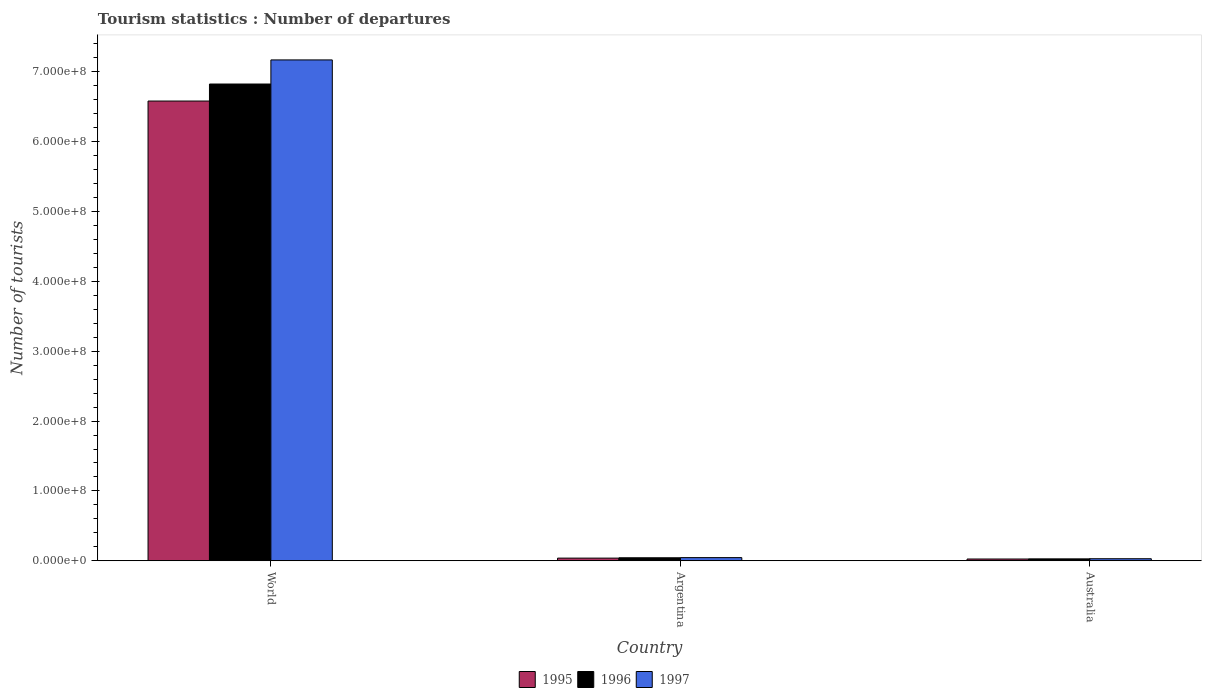Are the number of bars on each tick of the X-axis equal?
Make the answer very short. Yes. How many bars are there on the 3rd tick from the left?
Offer a terse response. 3. What is the label of the 3rd group of bars from the left?
Provide a succinct answer. Australia. In how many cases, is the number of bars for a given country not equal to the number of legend labels?
Your response must be concise. 0. What is the number of tourist departures in 1997 in Australia?
Your answer should be compact. 2.93e+06. Across all countries, what is the maximum number of tourist departures in 1997?
Your response must be concise. 7.17e+08. Across all countries, what is the minimum number of tourist departures in 1997?
Your answer should be very brief. 2.93e+06. In which country was the number of tourist departures in 1997 maximum?
Give a very brief answer. World. What is the total number of tourist departures in 1995 in the graph?
Keep it short and to the point. 6.65e+08. What is the difference between the number of tourist departures in 1995 in Argentina and that in Australia?
Provide a succinct answer. 1.30e+06. What is the difference between the number of tourist departures in 1997 in Australia and the number of tourist departures in 1995 in World?
Offer a very short reply. -6.55e+08. What is the average number of tourist departures in 1995 per country?
Your response must be concise. 2.22e+08. What is the difference between the number of tourist departures of/in 1995 and number of tourist departures of/in 1997 in World?
Your answer should be very brief. -5.89e+07. In how many countries, is the number of tourist departures in 1996 greater than 640000000?
Your response must be concise. 1. What is the ratio of the number of tourist departures in 1995 in Argentina to that in Australia?
Your answer should be very brief. 1.51. Is the number of tourist departures in 1997 in Argentina less than that in World?
Keep it short and to the point. Yes. Is the difference between the number of tourist departures in 1995 in Argentina and Australia greater than the difference between the number of tourist departures in 1997 in Argentina and Australia?
Provide a succinct answer. No. What is the difference between the highest and the second highest number of tourist departures in 1997?
Ensure brevity in your answer.  7.14e+08. What is the difference between the highest and the lowest number of tourist departures in 1995?
Keep it short and to the point. 6.56e+08. What does the 1st bar from the right in Australia represents?
Provide a short and direct response. 1997. Is it the case that in every country, the sum of the number of tourist departures in 1995 and number of tourist departures in 1997 is greater than the number of tourist departures in 1996?
Your answer should be compact. Yes. How many bars are there?
Your answer should be very brief. 9. What is the difference between two consecutive major ticks on the Y-axis?
Keep it short and to the point. 1.00e+08. What is the title of the graph?
Give a very brief answer. Tourism statistics : Number of departures. What is the label or title of the Y-axis?
Offer a terse response. Number of tourists. What is the Number of tourists in 1995 in World?
Provide a short and direct response. 6.58e+08. What is the Number of tourists of 1996 in World?
Provide a short and direct response. 6.83e+08. What is the Number of tourists in 1997 in World?
Your answer should be very brief. 7.17e+08. What is the Number of tourists of 1995 in Argentina?
Keep it short and to the point. 3.82e+06. What is the Number of tourists of 1996 in Argentina?
Ensure brevity in your answer.  4.30e+06. What is the Number of tourists in 1997 in Argentina?
Keep it short and to the point. 4.52e+06. What is the Number of tourists of 1995 in Australia?
Ensure brevity in your answer.  2.52e+06. What is the Number of tourists in 1996 in Australia?
Provide a succinct answer. 2.73e+06. What is the Number of tourists in 1997 in Australia?
Your response must be concise. 2.93e+06. Across all countries, what is the maximum Number of tourists of 1995?
Provide a short and direct response. 6.58e+08. Across all countries, what is the maximum Number of tourists in 1996?
Ensure brevity in your answer.  6.83e+08. Across all countries, what is the maximum Number of tourists of 1997?
Your response must be concise. 7.17e+08. Across all countries, what is the minimum Number of tourists of 1995?
Ensure brevity in your answer.  2.52e+06. Across all countries, what is the minimum Number of tourists in 1996?
Keep it short and to the point. 2.73e+06. Across all countries, what is the minimum Number of tourists of 1997?
Your answer should be compact. 2.93e+06. What is the total Number of tourists in 1995 in the graph?
Your answer should be compact. 6.65e+08. What is the total Number of tourists of 1996 in the graph?
Your answer should be compact. 6.90e+08. What is the total Number of tourists in 1997 in the graph?
Make the answer very short. 7.25e+08. What is the difference between the Number of tourists in 1995 in World and that in Argentina?
Give a very brief answer. 6.54e+08. What is the difference between the Number of tourists in 1996 in World and that in Argentina?
Give a very brief answer. 6.78e+08. What is the difference between the Number of tourists in 1997 in World and that in Argentina?
Provide a succinct answer. 7.13e+08. What is the difference between the Number of tourists in 1995 in World and that in Australia?
Offer a terse response. 6.56e+08. What is the difference between the Number of tourists in 1996 in World and that in Australia?
Provide a succinct answer. 6.80e+08. What is the difference between the Number of tourists in 1997 in World and that in Australia?
Provide a succinct answer. 7.14e+08. What is the difference between the Number of tourists in 1995 in Argentina and that in Australia?
Provide a short and direct response. 1.30e+06. What is the difference between the Number of tourists of 1996 in Argentina and that in Australia?
Keep it short and to the point. 1.56e+06. What is the difference between the Number of tourists in 1997 in Argentina and that in Australia?
Provide a succinct answer. 1.58e+06. What is the difference between the Number of tourists in 1995 in World and the Number of tourists in 1996 in Argentina?
Provide a succinct answer. 6.54e+08. What is the difference between the Number of tourists in 1995 in World and the Number of tourists in 1997 in Argentina?
Keep it short and to the point. 6.54e+08. What is the difference between the Number of tourists of 1996 in World and the Number of tourists of 1997 in Argentina?
Ensure brevity in your answer.  6.78e+08. What is the difference between the Number of tourists of 1995 in World and the Number of tourists of 1996 in Australia?
Ensure brevity in your answer.  6.56e+08. What is the difference between the Number of tourists of 1995 in World and the Number of tourists of 1997 in Australia?
Provide a short and direct response. 6.55e+08. What is the difference between the Number of tourists in 1996 in World and the Number of tourists in 1997 in Australia?
Your response must be concise. 6.80e+08. What is the difference between the Number of tourists of 1995 in Argentina and the Number of tourists of 1996 in Australia?
Offer a terse response. 1.08e+06. What is the difference between the Number of tourists of 1995 in Argentina and the Number of tourists of 1997 in Australia?
Your answer should be compact. 8.82e+05. What is the difference between the Number of tourists of 1996 in Argentina and the Number of tourists of 1997 in Australia?
Offer a very short reply. 1.36e+06. What is the average Number of tourists of 1995 per country?
Your response must be concise. 2.22e+08. What is the average Number of tourists of 1996 per country?
Give a very brief answer. 2.30e+08. What is the average Number of tourists of 1997 per country?
Give a very brief answer. 2.42e+08. What is the difference between the Number of tourists in 1995 and Number of tourists in 1996 in World?
Your response must be concise. -2.44e+07. What is the difference between the Number of tourists of 1995 and Number of tourists of 1997 in World?
Keep it short and to the point. -5.89e+07. What is the difference between the Number of tourists of 1996 and Number of tourists of 1997 in World?
Provide a succinct answer. -3.45e+07. What is the difference between the Number of tourists of 1995 and Number of tourists of 1996 in Argentina?
Your answer should be very brief. -4.81e+05. What is the difference between the Number of tourists in 1995 and Number of tourists in 1997 in Argentina?
Provide a succinct answer. -7.02e+05. What is the difference between the Number of tourists in 1996 and Number of tourists in 1997 in Argentina?
Offer a terse response. -2.21e+05. What is the difference between the Number of tourists of 1995 and Number of tourists of 1996 in Australia?
Your answer should be very brief. -2.13e+05. What is the difference between the Number of tourists in 1995 and Number of tourists in 1997 in Australia?
Your response must be concise. -4.14e+05. What is the difference between the Number of tourists of 1996 and Number of tourists of 1997 in Australia?
Provide a short and direct response. -2.01e+05. What is the ratio of the Number of tourists in 1995 in World to that in Argentina?
Provide a succinct answer. 172.54. What is the ratio of the Number of tourists in 1996 in World to that in Argentina?
Make the answer very short. 158.9. What is the ratio of the Number of tourists of 1997 in World to that in Argentina?
Ensure brevity in your answer.  158.76. What is the ratio of the Number of tourists of 1995 in World to that in Australia?
Provide a succinct answer. 261.32. What is the ratio of the Number of tourists in 1996 in World to that in Australia?
Give a very brief answer. 249.86. What is the ratio of the Number of tourists in 1997 in World to that in Australia?
Provide a short and direct response. 244.5. What is the ratio of the Number of tourists of 1995 in Argentina to that in Australia?
Provide a short and direct response. 1.51. What is the ratio of the Number of tourists of 1996 in Argentina to that in Australia?
Your response must be concise. 1.57. What is the ratio of the Number of tourists in 1997 in Argentina to that in Australia?
Your answer should be compact. 1.54. What is the difference between the highest and the second highest Number of tourists in 1995?
Your response must be concise. 6.54e+08. What is the difference between the highest and the second highest Number of tourists of 1996?
Give a very brief answer. 6.78e+08. What is the difference between the highest and the second highest Number of tourists in 1997?
Provide a succinct answer. 7.13e+08. What is the difference between the highest and the lowest Number of tourists of 1995?
Provide a short and direct response. 6.56e+08. What is the difference between the highest and the lowest Number of tourists of 1996?
Provide a succinct answer. 6.80e+08. What is the difference between the highest and the lowest Number of tourists of 1997?
Provide a short and direct response. 7.14e+08. 